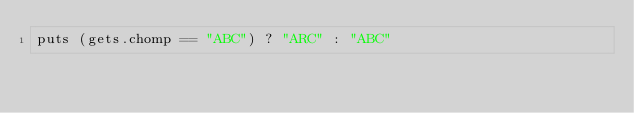<code> <loc_0><loc_0><loc_500><loc_500><_Ruby_>puts (gets.chomp == "ABC") ? "ARC" : "ABC"
</code> 